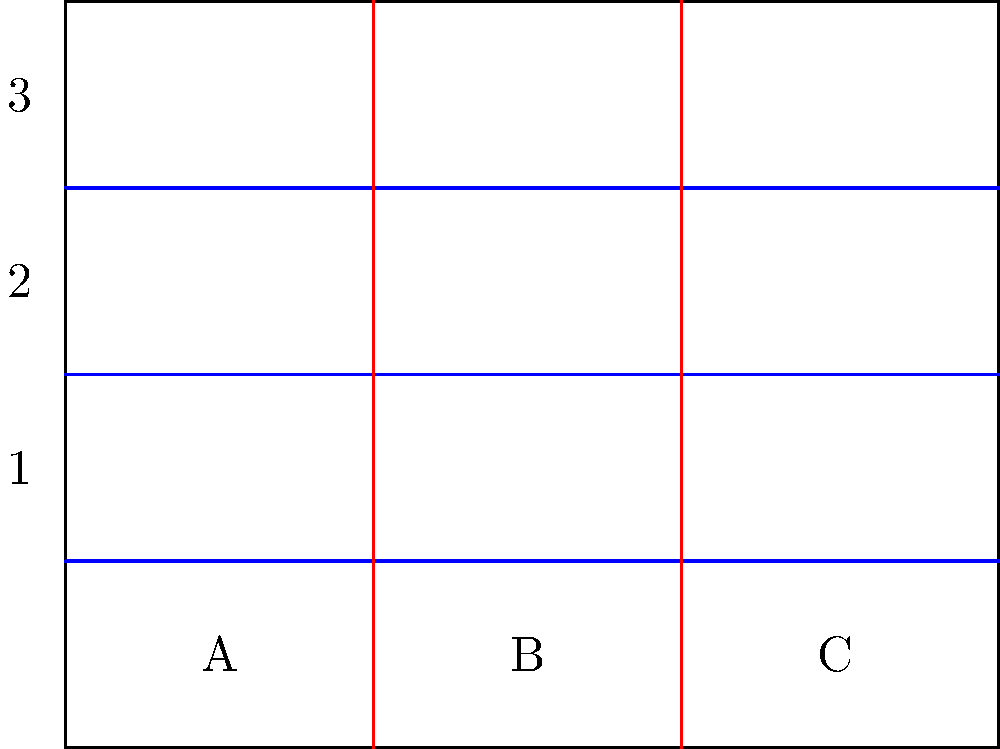In designing a closet for your twins' shared room, you're considering different shelf configurations to maximize storage space. The closet is divided into 3 vertical sections (A, B, C) and 3 horizontal levels (1, 2, 3). If you can choose to install a shelf in any of these 9 positions, how many unique shelf configurations are possible? To solve this problem, we'll use the concept of combinations from group theory. Here's a step-by-step approach:

1. Each of the 9 positions (3 vertical x 3 horizontal) can be in one of two states: with a shelf or without a shelf.

2. This means for each position, we have 2 choices.

3. Since we have 9 independent positions, and each position has 2 choices, we can use the multiplication principle.

4. The total number of possible configurations is:

   $$2^9 = 512$$

5. This includes the configuration with no shelves and the configuration with all 9 shelves installed.

6. We don't need to subtract any configurations because all of these are valid and unique.

Therefore, there are 512 unique shelf configurations possible in this closet design.
Answer: 512 configurations 